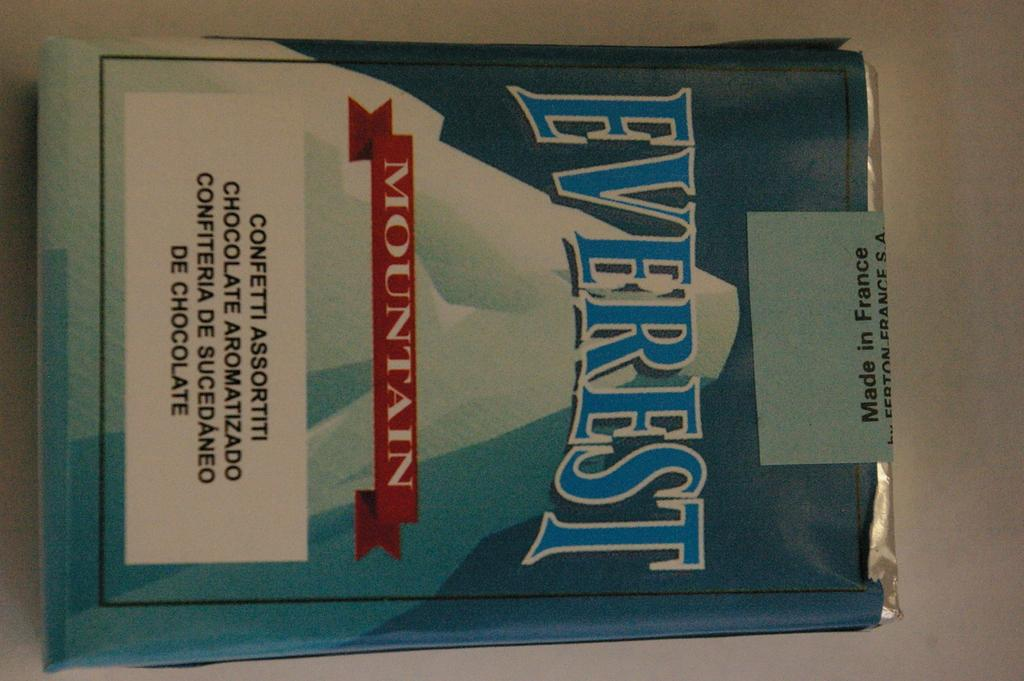<image>
Provide a brief description of the given image. Blue box showing a mountain with the words Everest on it. 